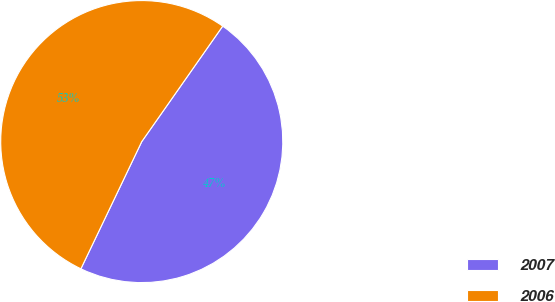Convert chart to OTSL. <chart><loc_0><loc_0><loc_500><loc_500><pie_chart><fcel>2007<fcel>2006<nl><fcel>47.37%<fcel>52.63%<nl></chart> 